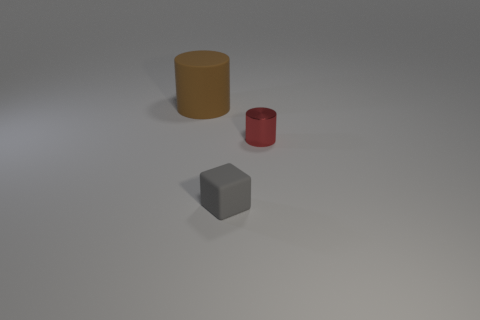There is a matte thing that is the same size as the metal cylinder; what shape is it? cube 